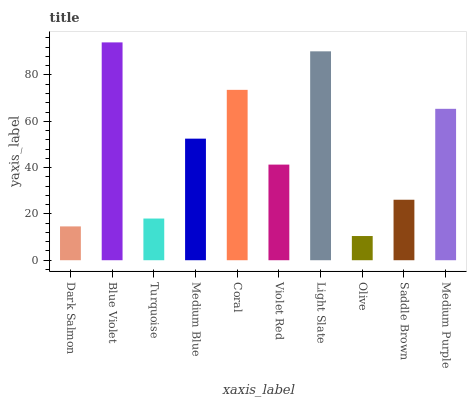Is Olive the minimum?
Answer yes or no. Yes. Is Blue Violet the maximum?
Answer yes or no. Yes. Is Turquoise the minimum?
Answer yes or no. No. Is Turquoise the maximum?
Answer yes or no. No. Is Blue Violet greater than Turquoise?
Answer yes or no. Yes. Is Turquoise less than Blue Violet?
Answer yes or no. Yes. Is Turquoise greater than Blue Violet?
Answer yes or no. No. Is Blue Violet less than Turquoise?
Answer yes or no. No. Is Medium Blue the high median?
Answer yes or no. Yes. Is Violet Red the low median?
Answer yes or no. Yes. Is Turquoise the high median?
Answer yes or no. No. Is Olive the low median?
Answer yes or no. No. 